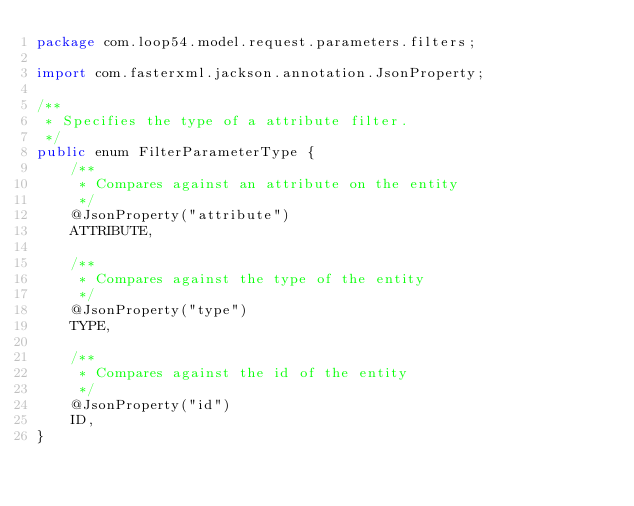<code> <loc_0><loc_0><loc_500><loc_500><_Java_>package com.loop54.model.request.parameters.filters;

import com.fasterxml.jackson.annotation.JsonProperty;

/**
 * Specifies the type of a attribute filter.
 */
public enum FilterParameterType {
    /**
     * Compares against an attribute on the entity
     */
    @JsonProperty("attribute")
    ATTRIBUTE,

    /**
     * Compares against the type of the entity
     */
    @JsonProperty("type")
    TYPE,

    /**
     * Compares against the id of the entity
     */
    @JsonProperty("id")
    ID,
}</code> 